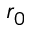<formula> <loc_0><loc_0><loc_500><loc_500>r _ { 0 }</formula> 